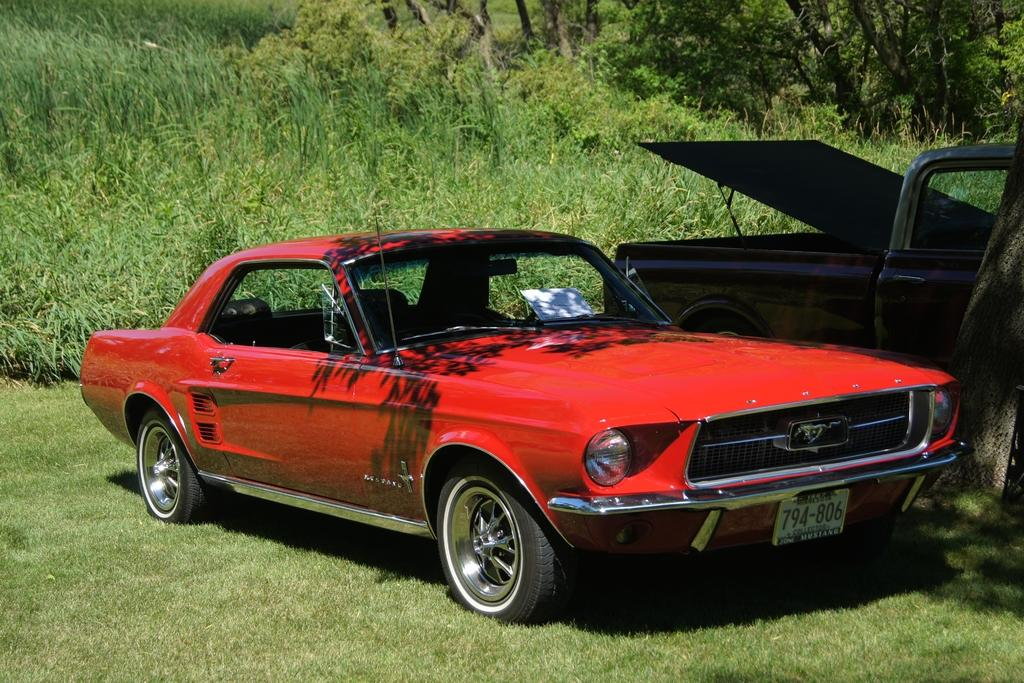How many vehicles can be seen in the image? There are two vehicles parked in the image. What color is one of the vehicles? One of the vehicles is a red car. What can be seen in the background of the image? There are plants and trees in the background of the image. Can you see any paint on the trees in the image? There is no paint visible on the trees in the image; they appear to be natural. 